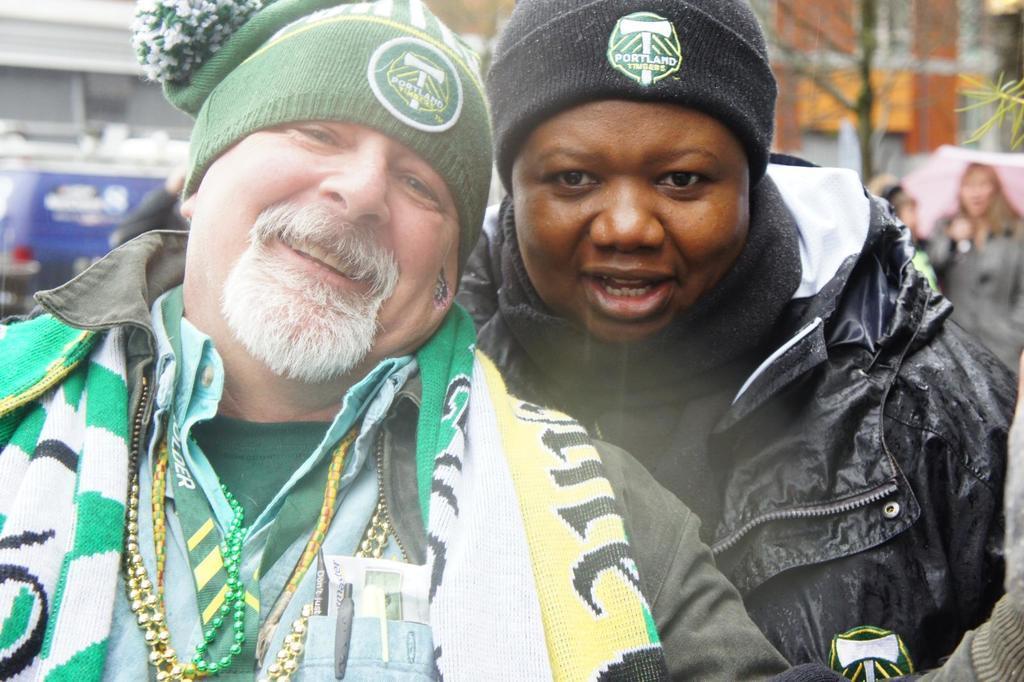In one or two sentences, can you explain what this image depicts? In this image i can see two men wearing jacket, cap posing for a photograph and in the background of the image there are some persons, vehicles and buildings. 